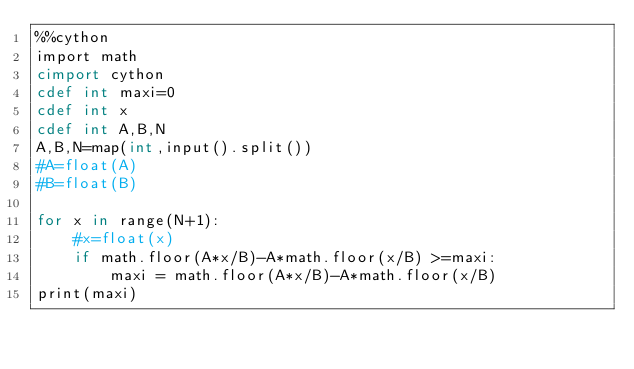<code> <loc_0><loc_0><loc_500><loc_500><_Cython_>%%cython
import math
cimport cython
cdef int maxi=0
cdef int x
cdef int A,B,N
A,B,N=map(int,input().split())
#A=float(A)
#B=float(B)
 
for x in range(N+1):
    #x=float(x)
    if math.floor(A*x/B)-A*math.floor(x/B) >=maxi:
        maxi = math.floor(A*x/B)-A*math.floor(x/B)
print(maxi)</code> 